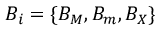<formula> <loc_0><loc_0><loc_500><loc_500>B _ { i } = \{ B _ { M } , B _ { m } , B _ { X } \}</formula> 